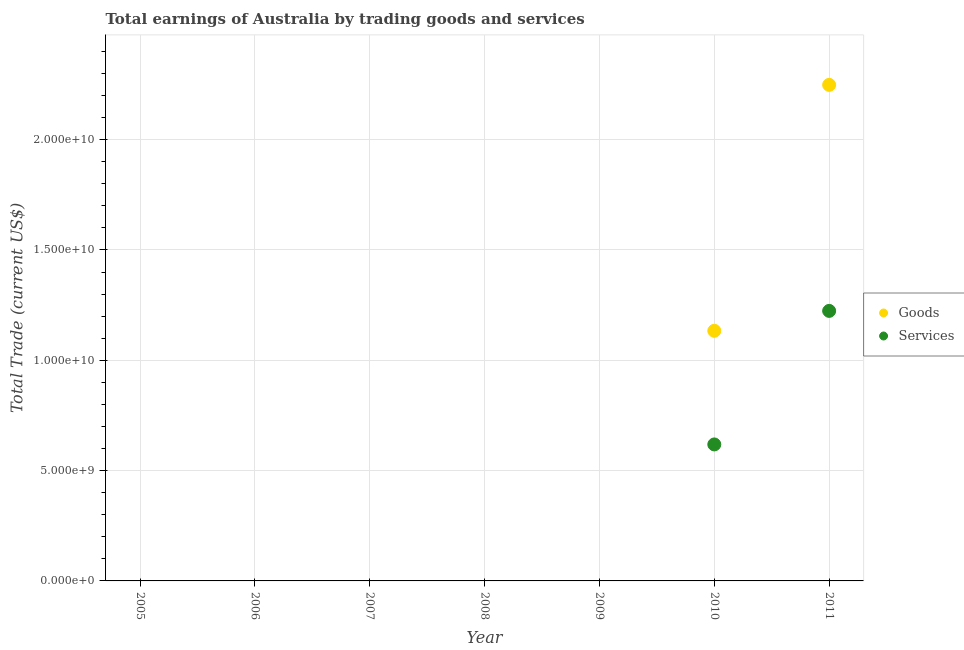What is the amount earned by trading goods in 2010?
Provide a succinct answer. 1.13e+1. Across all years, what is the maximum amount earned by trading goods?
Offer a very short reply. 2.25e+1. Across all years, what is the minimum amount earned by trading services?
Your answer should be very brief. 0. In which year was the amount earned by trading goods maximum?
Make the answer very short. 2011. What is the total amount earned by trading services in the graph?
Your answer should be very brief. 1.84e+1. What is the difference between the amount earned by trading services in 2006 and the amount earned by trading goods in 2005?
Provide a succinct answer. 0. What is the average amount earned by trading services per year?
Your response must be concise. 2.63e+09. In the year 2011, what is the difference between the amount earned by trading services and amount earned by trading goods?
Offer a terse response. -1.02e+1. In how many years, is the amount earned by trading services greater than 14000000000 US$?
Offer a terse response. 0. Is the amount earned by trading services in 2010 less than that in 2011?
Offer a very short reply. Yes. What is the difference between the highest and the lowest amount earned by trading services?
Your answer should be compact. 1.22e+1. Is the amount earned by trading services strictly less than the amount earned by trading goods over the years?
Offer a terse response. Yes. How many dotlines are there?
Make the answer very short. 2. Where does the legend appear in the graph?
Make the answer very short. Center right. How are the legend labels stacked?
Offer a very short reply. Vertical. What is the title of the graph?
Ensure brevity in your answer.  Total earnings of Australia by trading goods and services. Does "Enforce a contract" appear as one of the legend labels in the graph?
Offer a terse response. No. What is the label or title of the X-axis?
Your response must be concise. Year. What is the label or title of the Y-axis?
Ensure brevity in your answer.  Total Trade (current US$). What is the Total Trade (current US$) in Goods in 2005?
Ensure brevity in your answer.  0. What is the Total Trade (current US$) of Services in 2005?
Your answer should be very brief. 0. What is the Total Trade (current US$) in Services in 2006?
Your answer should be compact. 0. What is the Total Trade (current US$) of Goods in 2009?
Your response must be concise. 0. What is the Total Trade (current US$) in Goods in 2010?
Offer a terse response. 1.13e+1. What is the Total Trade (current US$) of Services in 2010?
Your answer should be very brief. 6.19e+09. What is the Total Trade (current US$) in Goods in 2011?
Your answer should be very brief. 2.25e+1. What is the Total Trade (current US$) in Services in 2011?
Keep it short and to the point. 1.22e+1. Across all years, what is the maximum Total Trade (current US$) in Goods?
Offer a terse response. 2.25e+1. Across all years, what is the maximum Total Trade (current US$) in Services?
Provide a succinct answer. 1.22e+1. What is the total Total Trade (current US$) in Goods in the graph?
Provide a short and direct response. 3.38e+1. What is the total Total Trade (current US$) in Services in the graph?
Keep it short and to the point. 1.84e+1. What is the difference between the Total Trade (current US$) in Goods in 2010 and that in 2011?
Make the answer very short. -1.11e+1. What is the difference between the Total Trade (current US$) of Services in 2010 and that in 2011?
Your answer should be very brief. -6.05e+09. What is the difference between the Total Trade (current US$) in Goods in 2010 and the Total Trade (current US$) in Services in 2011?
Your response must be concise. -9.02e+08. What is the average Total Trade (current US$) in Goods per year?
Your response must be concise. 4.83e+09. What is the average Total Trade (current US$) in Services per year?
Provide a succinct answer. 2.63e+09. In the year 2010, what is the difference between the Total Trade (current US$) of Goods and Total Trade (current US$) of Services?
Your answer should be very brief. 5.15e+09. In the year 2011, what is the difference between the Total Trade (current US$) of Goods and Total Trade (current US$) of Services?
Make the answer very short. 1.02e+1. What is the ratio of the Total Trade (current US$) of Goods in 2010 to that in 2011?
Your answer should be very brief. 0.5. What is the ratio of the Total Trade (current US$) of Services in 2010 to that in 2011?
Provide a short and direct response. 0.51. What is the difference between the highest and the lowest Total Trade (current US$) of Goods?
Offer a very short reply. 2.25e+1. What is the difference between the highest and the lowest Total Trade (current US$) in Services?
Keep it short and to the point. 1.22e+1. 